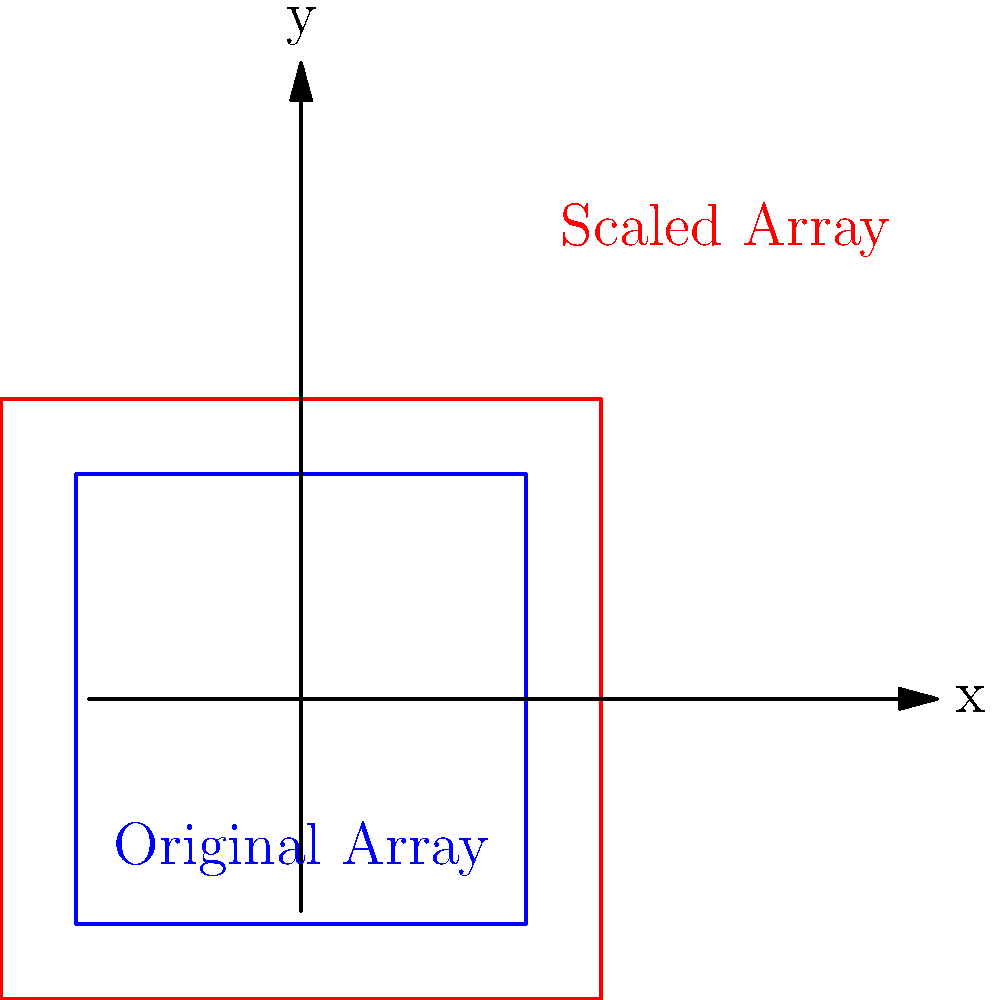As a spokesperson for a renewable energy company, you're discussing the scalability of solar panel arrays. The diagram shows an original square solar panel array (blue) and a scaled version (red). If the original array has an area of 9 square meters and produces 1.8 kW of power, what would be the power output of the scaled array assuming a linear relationship between area and power output? Let's approach this step-by-step:

1) First, we need to determine the scale factor between the original and scaled arrays.
   - The original array is a 1.5 unit square (side length = 1.5).
   - The scaled array is a 2 unit square (side length = 2).
   - Scale factor = $\frac{2}{1.5} = \frac{4}{3}$

2) Now, let's calculate how the area has changed:
   - Area scale factor = (linear scale factor)² = $(\frac{4}{3})^2 = \frac{16}{9}$

3) If the original array has an area of 9 square meters, the scaled array's area is:
   $9 * \frac{16}{9} = 16$ square meters

4) We're told there's a linear relationship between area and power output.
   - Original array: 9 m² produces 1.8 kW
   - Scaled array: 16 m²

5) Set up a proportion to solve for the new power output (x):
   $\frac{9 \text{ m}^2}{1.8 \text{ kW}} = \frac{16 \text{ m}^2}{x \text{ kW}}$

6) Cross multiply and solve for x:
   $9x = 1.8 * 16$
   $x = \frac{1.8 * 16}{9} = 3.2$

Therefore, the scaled array would produce 3.2 kW of power.
Answer: 3.2 kW 